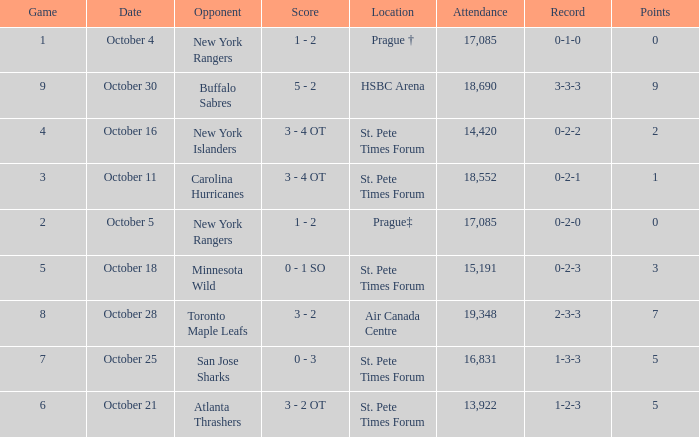What was the attendance when their record stood at 0-2-2? 14420.0. 